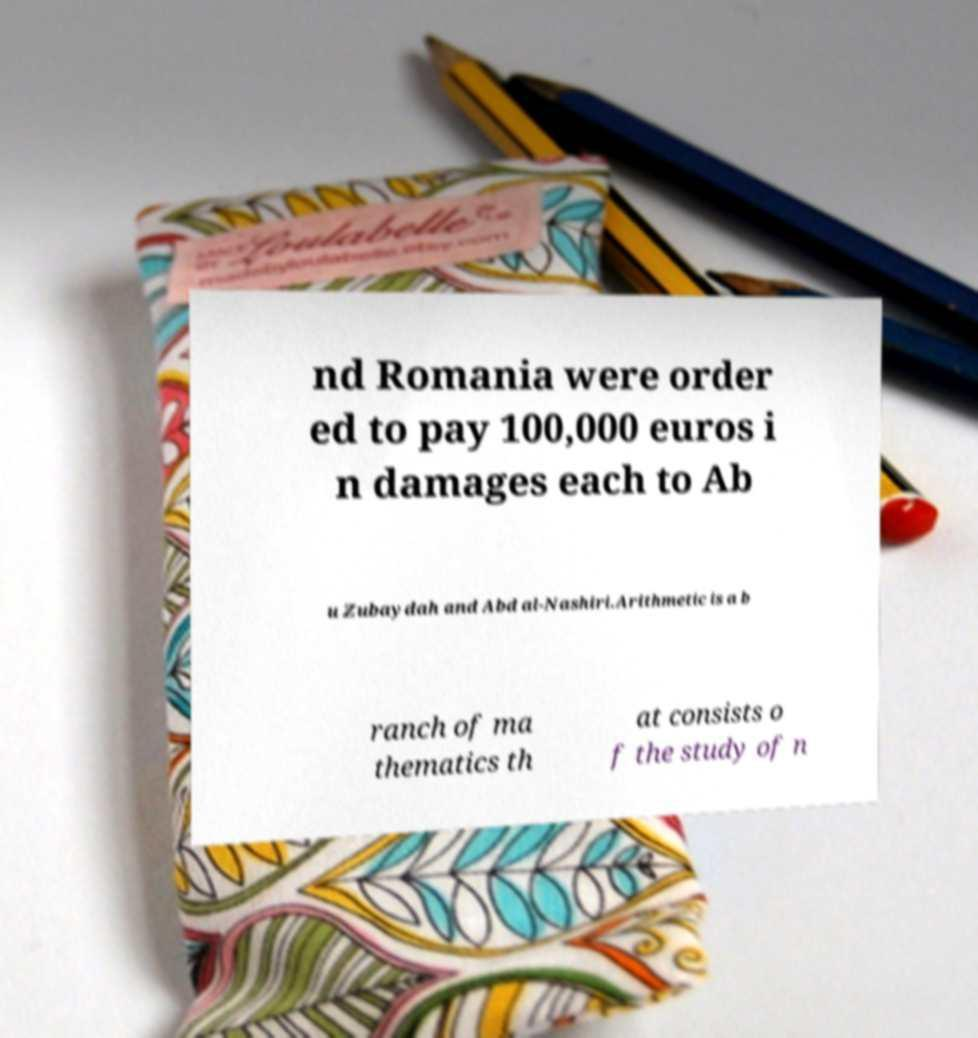Can you accurately transcribe the text from the provided image for me? nd Romania were order ed to pay 100,000 euros i n damages each to Ab u Zubaydah and Abd al-Nashiri.Arithmetic is a b ranch of ma thematics th at consists o f the study of n 